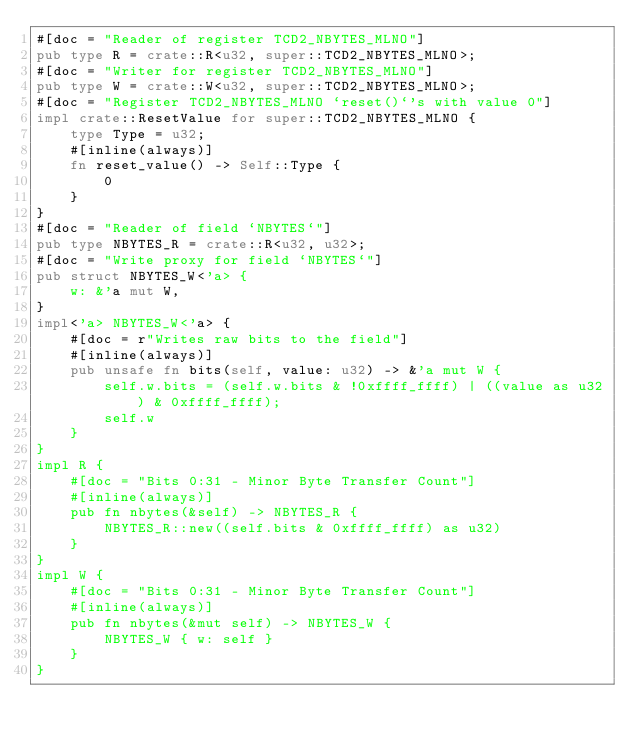<code> <loc_0><loc_0><loc_500><loc_500><_Rust_>#[doc = "Reader of register TCD2_NBYTES_MLNO"]
pub type R = crate::R<u32, super::TCD2_NBYTES_MLNO>;
#[doc = "Writer for register TCD2_NBYTES_MLNO"]
pub type W = crate::W<u32, super::TCD2_NBYTES_MLNO>;
#[doc = "Register TCD2_NBYTES_MLNO `reset()`'s with value 0"]
impl crate::ResetValue for super::TCD2_NBYTES_MLNO {
    type Type = u32;
    #[inline(always)]
    fn reset_value() -> Self::Type {
        0
    }
}
#[doc = "Reader of field `NBYTES`"]
pub type NBYTES_R = crate::R<u32, u32>;
#[doc = "Write proxy for field `NBYTES`"]
pub struct NBYTES_W<'a> {
    w: &'a mut W,
}
impl<'a> NBYTES_W<'a> {
    #[doc = r"Writes raw bits to the field"]
    #[inline(always)]
    pub unsafe fn bits(self, value: u32) -> &'a mut W {
        self.w.bits = (self.w.bits & !0xffff_ffff) | ((value as u32) & 0xffff_ffff);
        self.w
    }
}
impl R {
    #[doc = "Bits 0:31 - Minor Byte Transfer Count"]
    #[inline(always)]
    pub fn nbytes(&self) -> NBYTES_R {
        NBYTES_R::new((self.bits & 0xffff_ffff) as u32)
    }
}
impl W {
    #[doc = "Bits 0:31 - Minor Byte Transfer Count"]
    #[inline(always)]
    pub fn nbytes(&mut self) -> NBYTES_W {
        NBYTES_W { w: self }
    }
}
</code> 